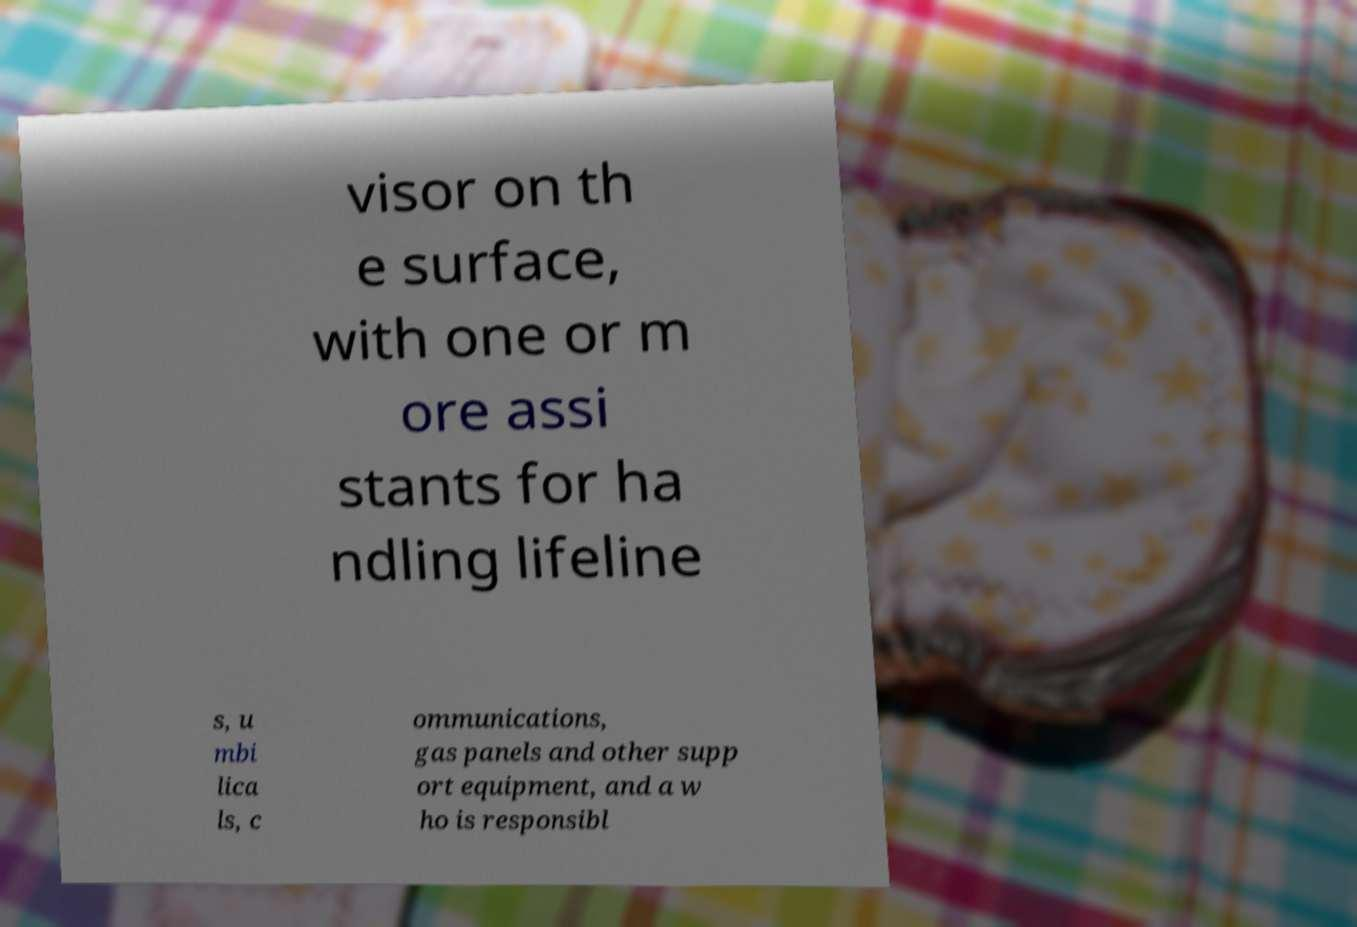Could you extract and type out the text from this image? visor on th e surface, with one or m ore assi stants for ha ndling lifeline s, u mbi lica ls, c ommunications, gas panels and other supp ort equipment, and a w ho is responsibl 